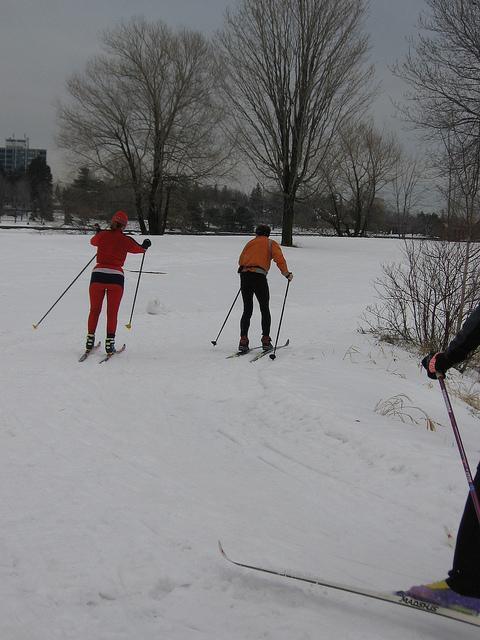How many people are in this photo?
Give a very brief answer. 3. How many people are in the photo?
Give a very brief answer. 3. How many orange trucks are there?
Give a very brief answer. 0. 